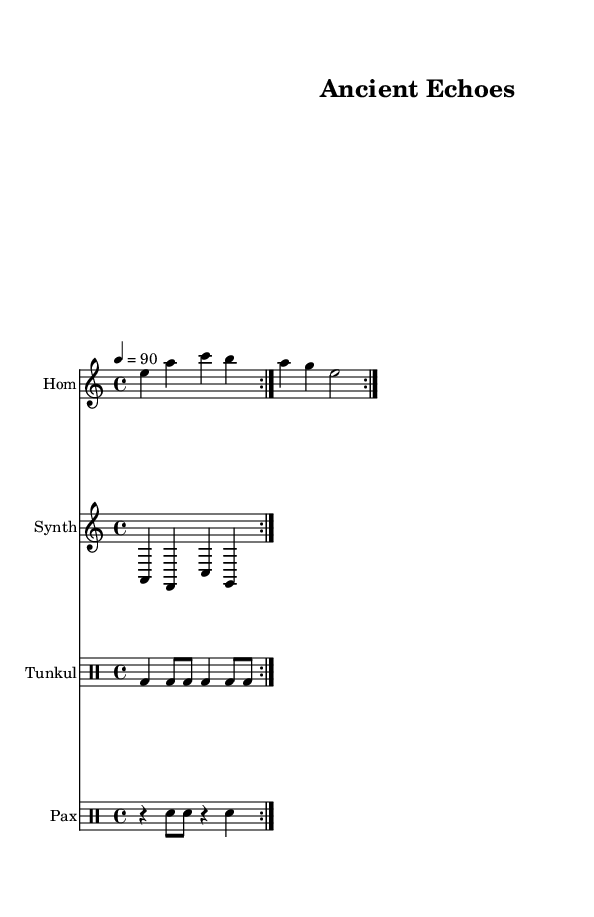What is the key signature of this music? The key signature is A minor, identified by the absence of sharps and flats. The music notation indicates one sharp, F#, which is typical for the A minor key.
Answer: A minor What is the time signature of this music? The time signature is 4/4, shown at the beginning of the score under the global settings. It indicates four beats per measure.
Answer: 4/4 What is the tempo marking given in the sheet music? The tempo marking states "4 = 90," which means there are 90 beats per minute, corresponding to four quarter notes in each measure at that speed.
Answer: 90 How many measures are in the Hom part? The Hom part repeats twice and contains four measures in total, as seen by the repeat markings. Each repetition includes two measures of music.
Answer: 4 What instruments are used in this composition? The instruments listed are Hom, Synth, Tunkul, and Pax, which are identified in the respective staff headings, indicating a blend of traditional and modern elements.
Answer: Hom, Synth, Tunkul, Pax How many rhythmic patterns does the Tunkul section repeat? The Tunkul section features a rhythmic pattern that repeats two times, denoted by the "volta" repeat marking, meaning the same pattern plays again.
Answer: 2 